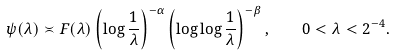Convert formula to latex. <formula><loc_0><loc_0><loc_500><loc_500>\psi ( \lambda ) \asymp F ( \lambda ) \left ( \log \frac { 1 } { \lambda } \right ) ^ { - \alpha } \left ( \log \log \frac { 1 } { \lambda } \right ) ^ { - \beta } , \quad 0 < \lambda < 2 ^ { - 4 } .</formula> 